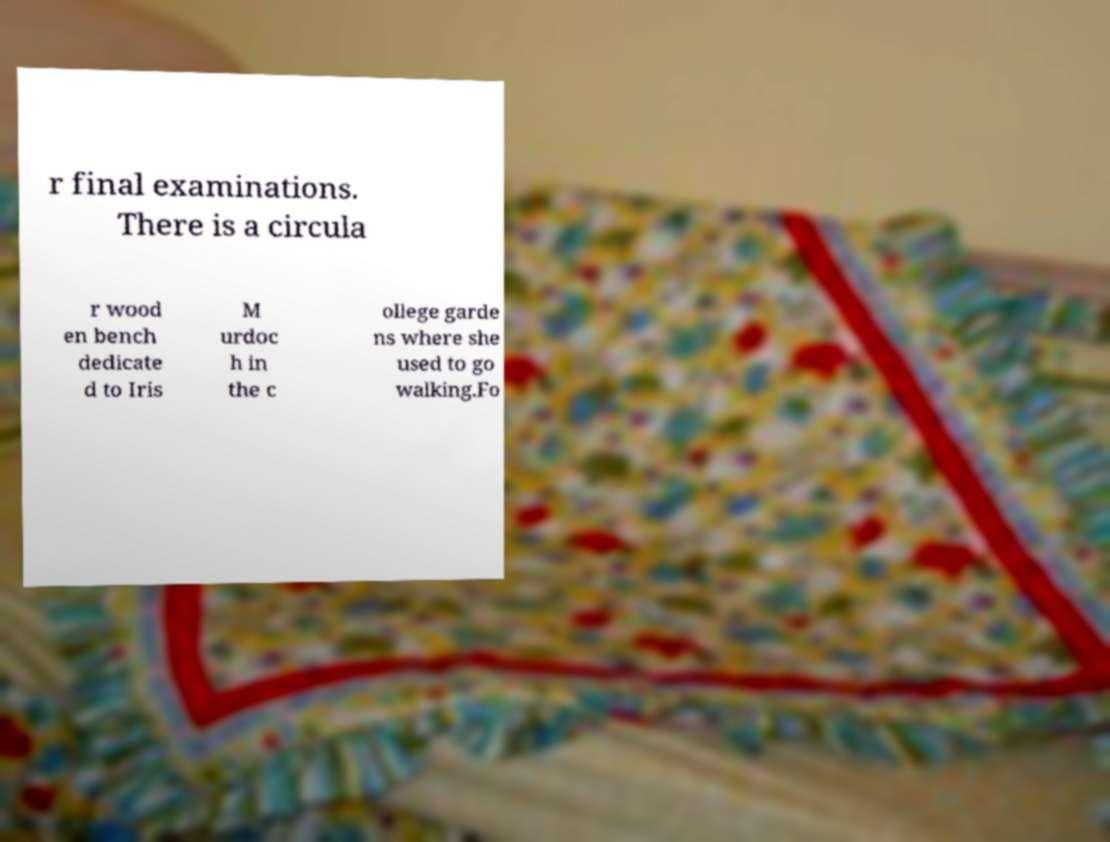Could you assist in decoding the text presented in this image and type it out clearly? r final examinations. There is a circula r wood en bench dedicate d to Iris M urdoc h in the c ollege garde ns where she used to go walking.Fo 